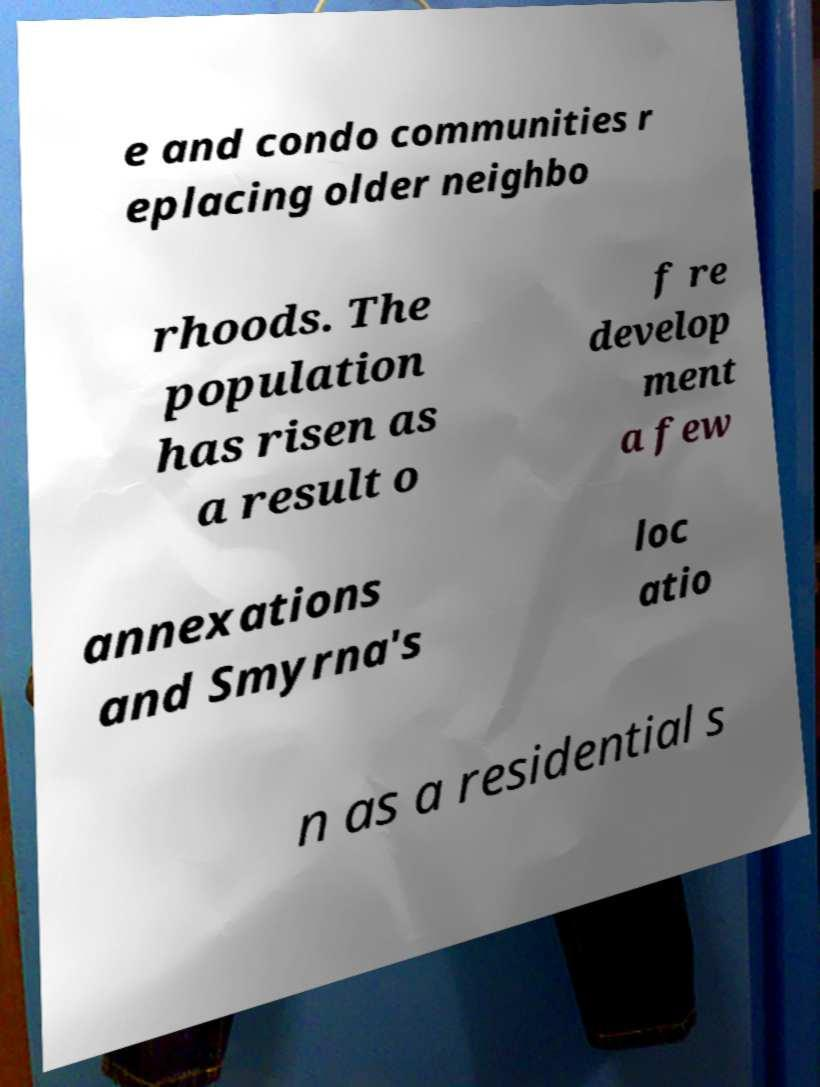Could you extract and type out the text from this image? e and condo communities r eplacing older neighbo rhoods. The population has risen as a result o f re develop ment a few annexations and Smyrna's loc atio n as a residential s 